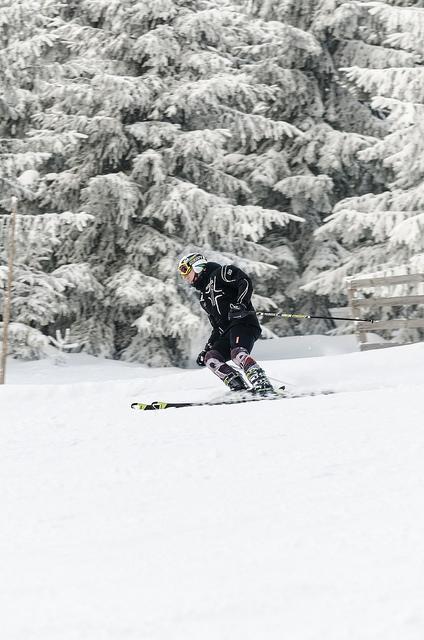Why do skiers wear suits?
Indicate the correct response by choosing from the four available options to answer the question.
Options: Pilgrims, bikini, ski suit, snowsuit. Snowsuit. 